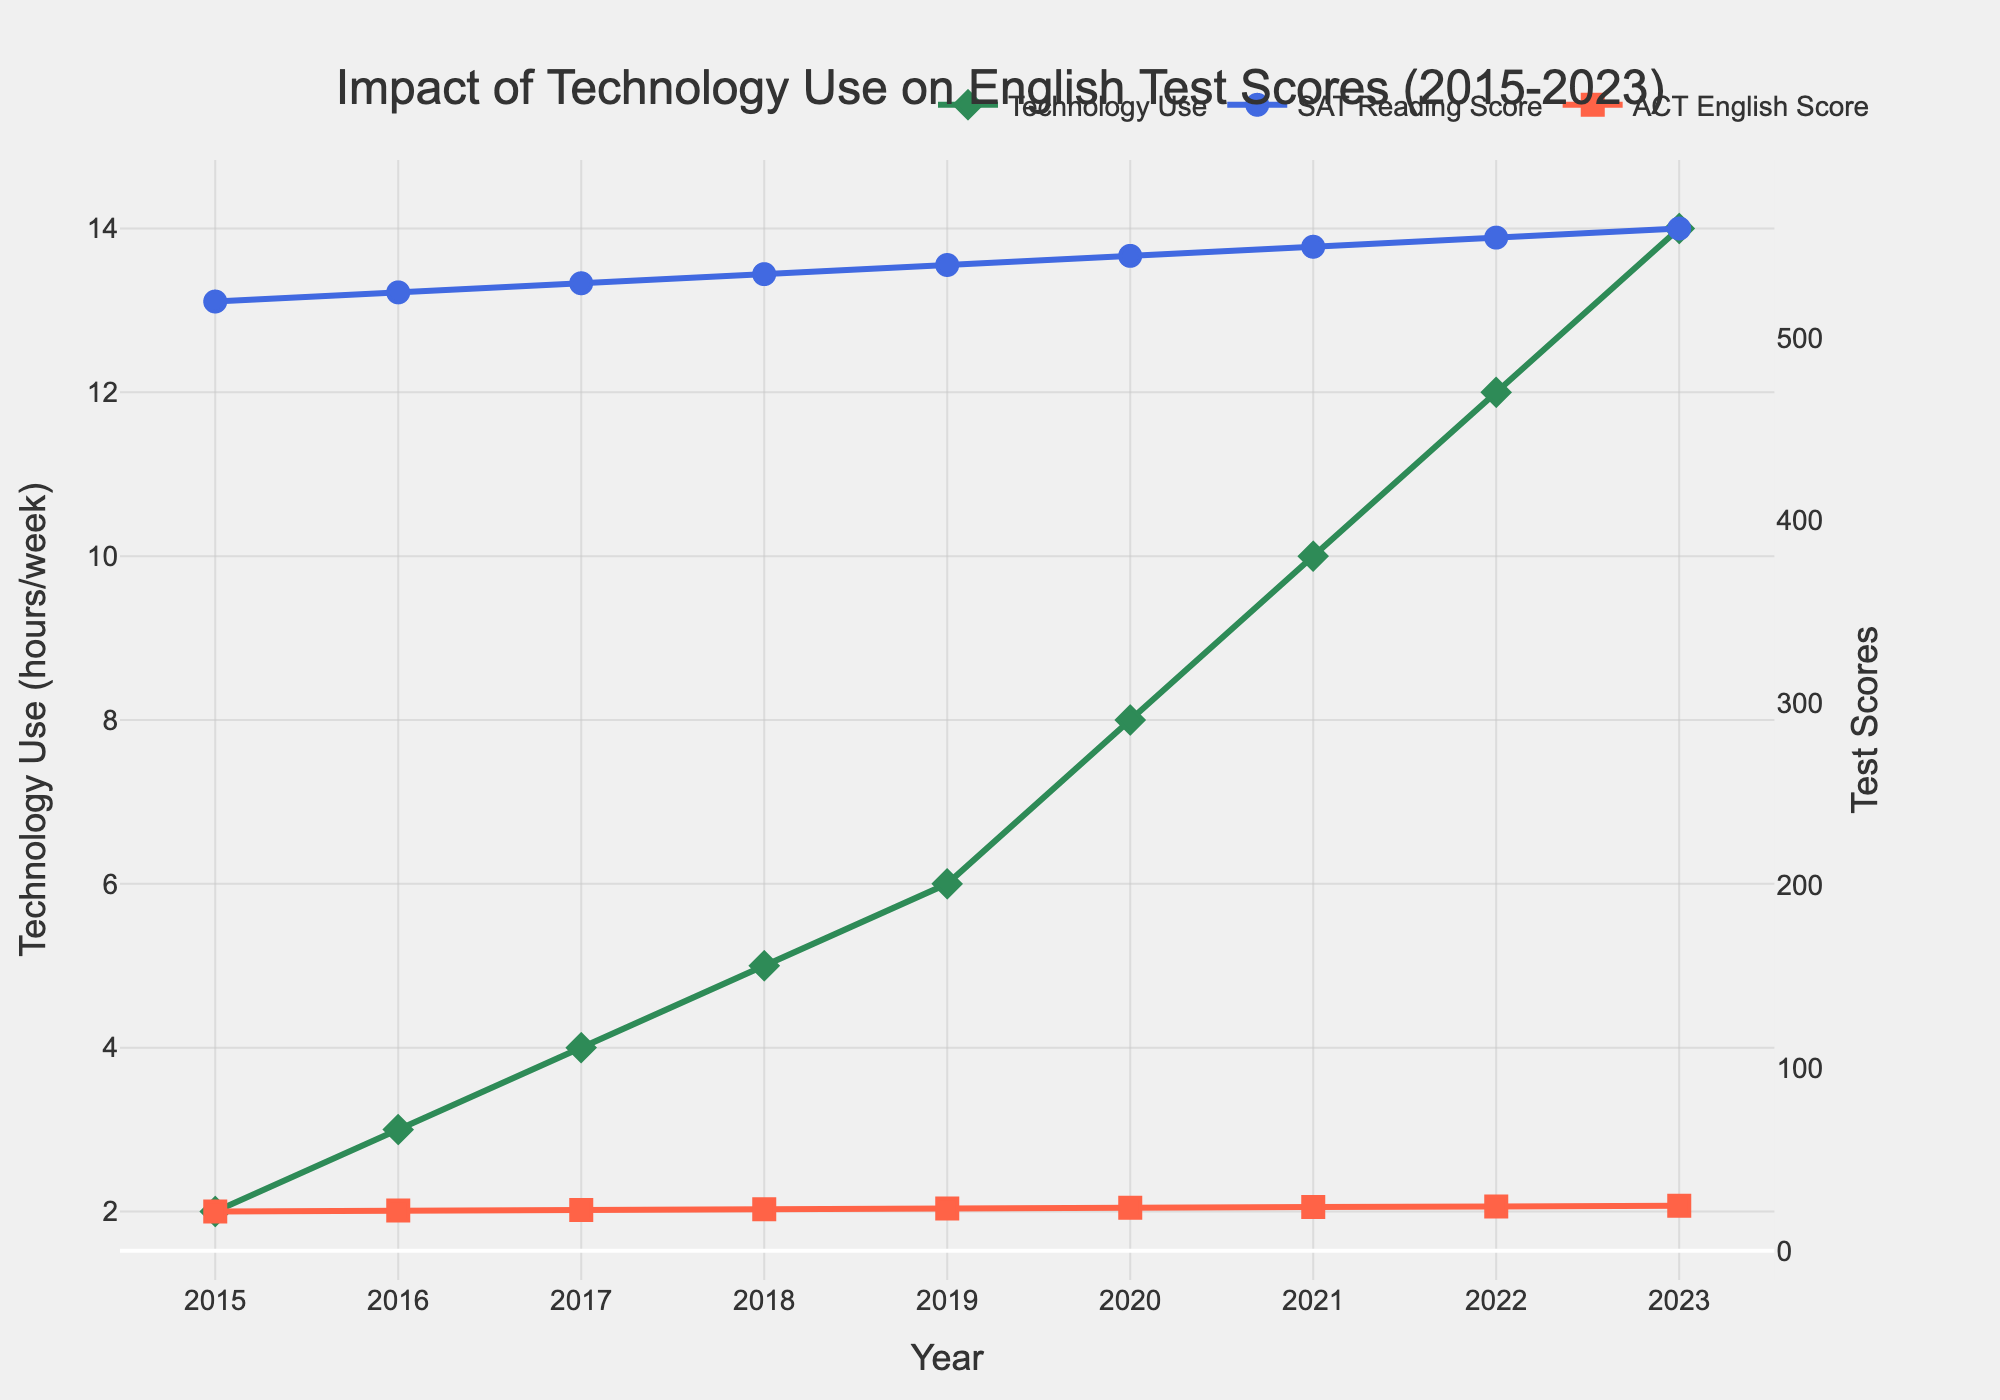How has the frequency of technology use changed from 2015 to 2023? The figure shows the frequency of technology use in hours per week on the primary y-axis. In 2015, it was 2 hours per week and it increased steadily each year, reaching 14 hours per week in 2023.
Answer: Increased from 2 to 14 hours per week Between which two consecutive years was the largest increase in Average SAT Reading Scores observed? By examining the line for SAT Reading Scores on the secondary y-axis, the largest increase appears between 2018 and 2019, where the score increased from 535 to 540.
Answer: Between 2018 and 2019 What was the average ACT English Score over the entire period shown in the chart? Calculate the average by summing the ACT English Scores from 2015 to 2023 and dividing by the number of years. The sum (21.5 + 22.0 + 22.3 + 22.7 + 23.1 + 23.5 + 23.9 + 24.2 + 24.6) = 207.8. There are 9 years, so the average is 207.8 / 9 = 23.09.
Answer: 23.09 Which year had the smallest disparity between SAT Reading Score and ACT English Score? Look for the year where the difference between the SAT Reading Score and ACT English Score is the smallest. In 2015, the disparity is 520 - 21.5 = 498.5, in 2016 it is 503, in 2017 it is 507.7, and so on. The smallest disparity is in 2023, where the difference is 560 - 24.6 = 535.4.
Answer: 2015 How much did the Average SAT Reading Score increase from 2015 to 2023? Subtract the score in 2015 from the score in 2023. The score increased from 520 in 2015 to 560 in 2023, so the difference is 560 - 520 = 40.
Answer: 40 points In which year did the Technology Use Frequency surpass 8 hours per week, and what were the corresponding test scores in that year? The figure shows that in 2021, the Technology Use Frequency was 10 hours per week, the first time it surpassed 8 hours. The SAT Reading Score was 550, and the ACT English Score was 23.9 in 2021.
Answer: 2021, SAT: 550, ACT: 23.9 Compare the trend of Technology Use Frequency and SAT Reading Scores from 2015 to 2023. Both the Technology Use Frequency and SAT Reading Scores show an upward trend from 2015 to 2023. Technology Use Frequency increases from 2 to 14 hours per week, while the SAT Reading Score increases from 520 to 560.
Answer: Both increased steadily Which year had the highest ACT English Score, and what was the Technology Use Frequency that year? The highest ACT English Score is in 2023 at 24.6. The corresponding Technology Use Frequency is 14 hours per week.
Answer: 2023, 14 hours per week Which score, SAT Reading or ACT English, shows a more consistent rate of increase over the years? By examining the lines on the secondary y-axis, the SAT Reading Score shows a more linear and consistent rate of increase compared to the ACT English Score, which has smaller and slightly less consistent increments.
Answer: SAT Reading Score Are there any years where the SAT Reading Score decreased? By scanning the figure, it is evident that there are no years where the SAT Reading Score decreased; it consistently increased each year from 2015 to 2023.
Answer: No 